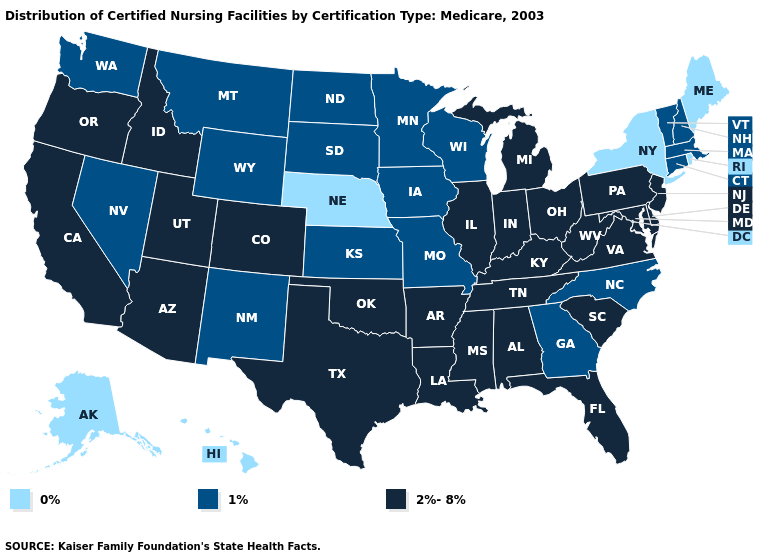Name the states that have a value in the range 1%?
Be succinct. Connecticut, Georgia, Iowa, Kansas, Massachusetts, Minnesota, Missouri, Montana, Nevada, New Hampshire, New Mexico, North Carolina, North Dakota, South Dakota, Vermont, Washington, Wisconsin, Wyoming. Among the states that border Vermont , which have the lowest value?
Answer briefly. New York. What is the value of Connecticut?
Short answer required. 1%. What is the value of Hawaii?
Short answer required. 0%. Does the map have missing data?
Short answer required. No. Name the states that have a value in the range 0%?
Answer briefly. Alaska, Hawaii, Maine, Nebraska, New York, Rhode Island. What is the value of Pennsylvania?
Keep it brief. 2%-8%. Which states hav the highest value in the MidWest?
Be succinct. Illinois, Indiana, Michigan, Ohio. Does the map have missing data?
Answer briefly. No. How many symbols are there in the legend?
Write a very short answer. 3. Name the states that have a value in the range 0%?
Be succinct. Alaska, Hawaii, Maine, Nebraska, New York, Rhode Island. Name the states that have a value in the range 0%?
Be succinct. Alaska, Hawaii, Maine, Nebraska, New York, Rhode Island. Among the states that border North Dakota , which have the lowest value?
Write a very short answer. Minnesota, Montana, South Dakota. What is the value of Arkansas?
Keep it brief. 2%-8%. How many symbols are there in the legend?
Short answer required. 3. 